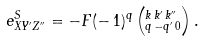Convert formula to latex. <formula><loc_0><loc_0><loc_500><loc_500>e _ { X Y ^ { \prime } Z ^ { \prime \prime } } ^ { S } = - F ( - \, 1 ) ^ { q } \left ( ^ { k \, k ^ { \prime } \, k ^ { \prime \prime } } _ { q \, - q ^ { \prime } \, 0 } \right ) .</formula> 